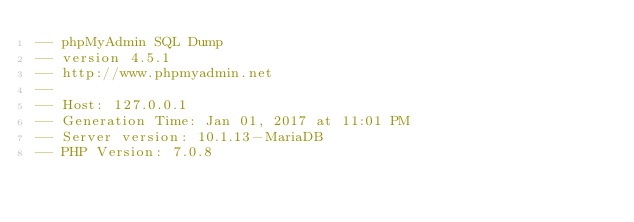Convert code to text. <code><loc_0><loc_0><loc_500><loc_500><_SQL_>-- phpMyAdmin SQL Dump
-- version 4.5.1
-- http://www.phpmyadmin.net
--
-- Host: 127.0.0.1
-- Generation Time: Jan 01, 2017 at 11:01 PM
-- Server version: 10.1.13-MariaDB
-- PHP Version: 7.0.8
</code> 